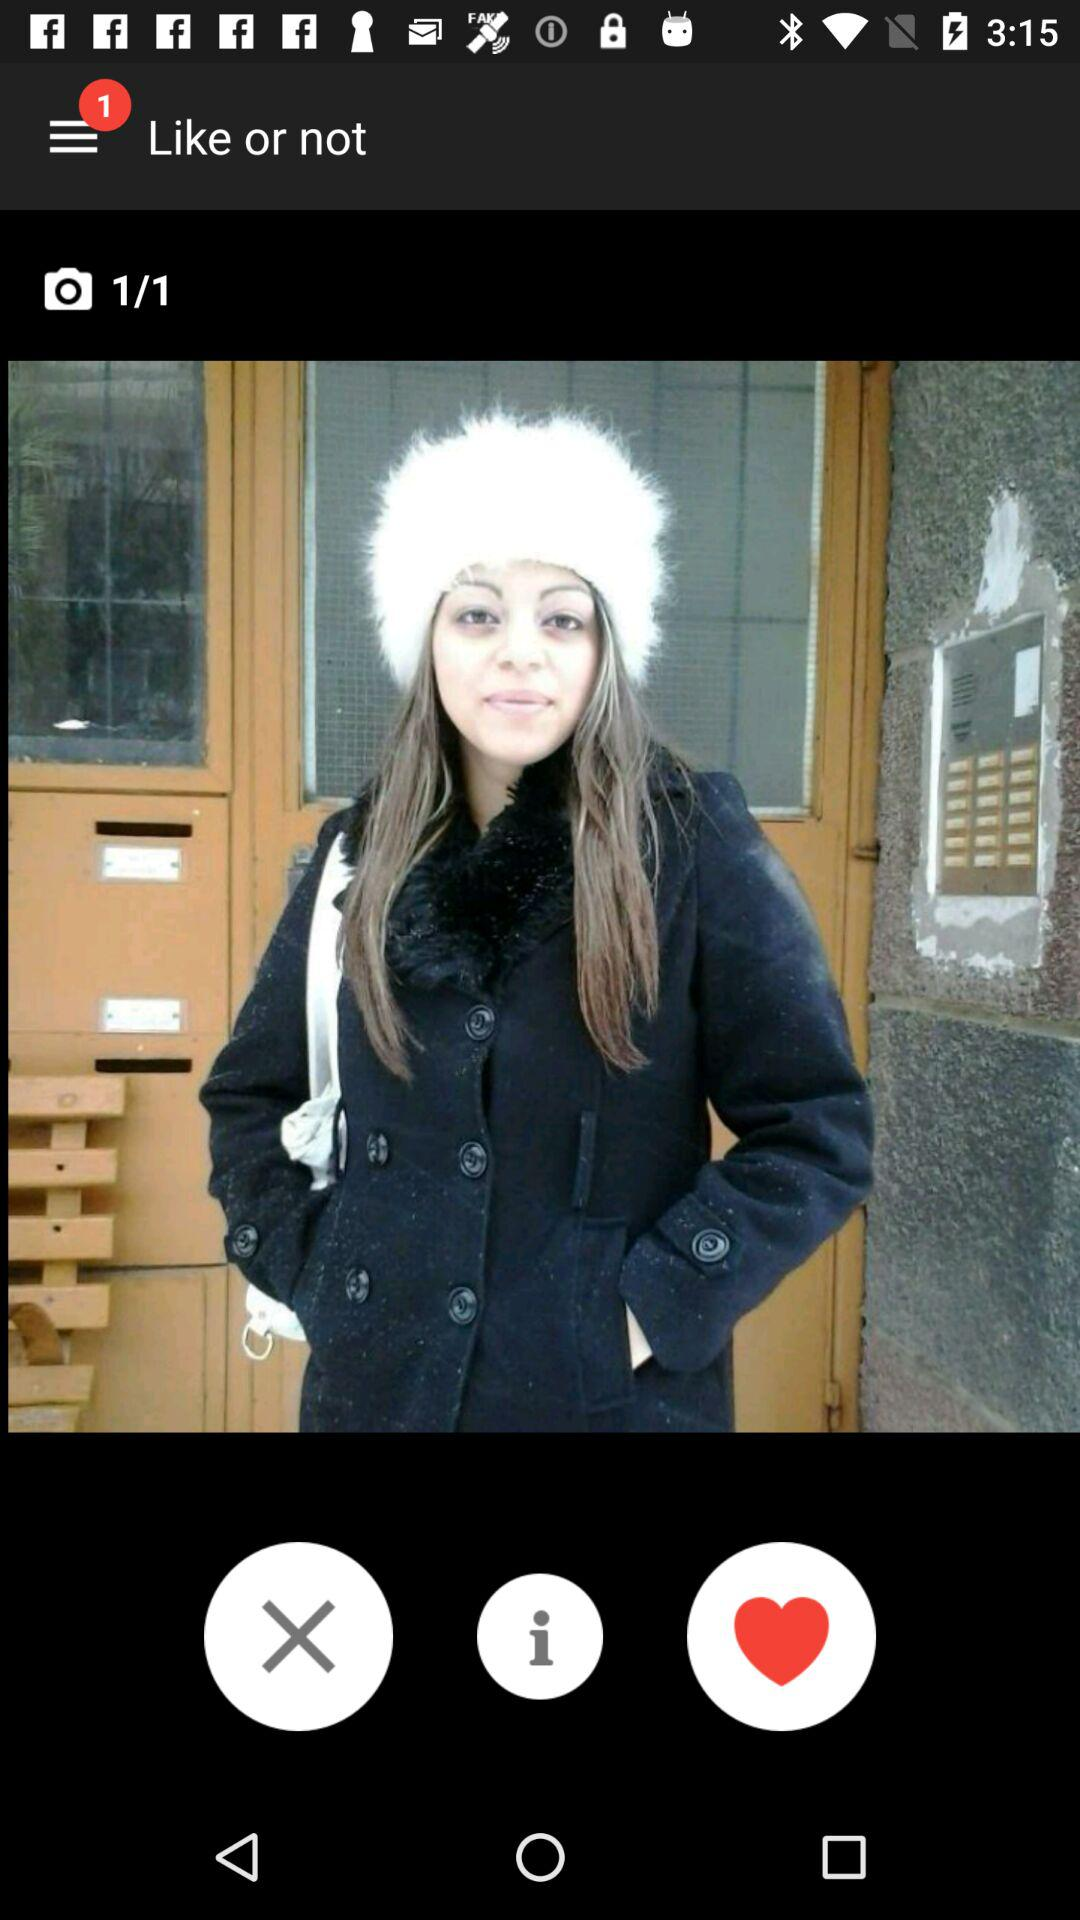How many photos in total are there? There is one photo in total. 